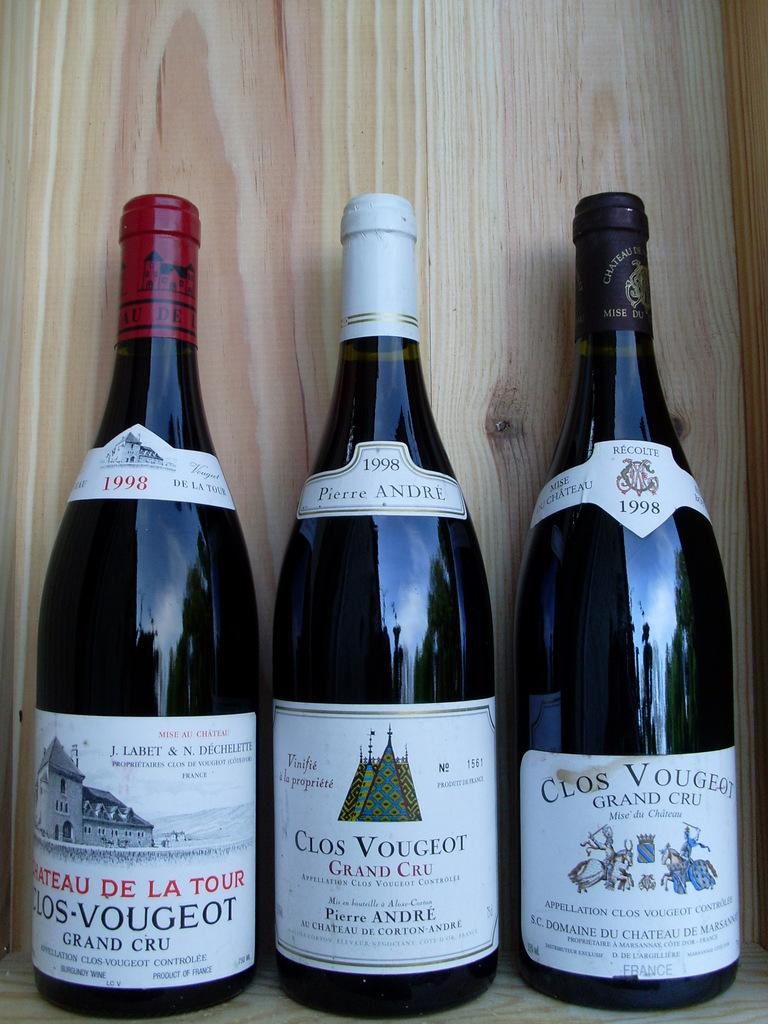Provide a one-sentence caption for the provided image. Three bottles of wine are displayed side by side. 